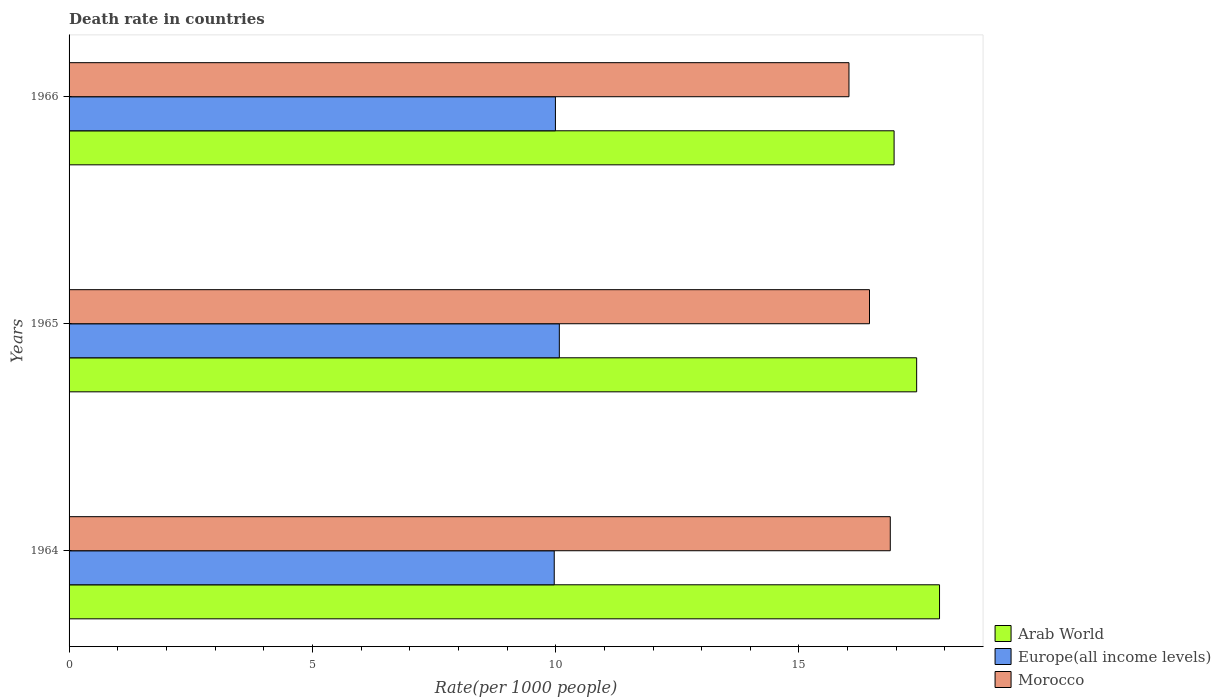How many different coloured bars are there?
Give a very brief answer. 3. Are the number of bars on each tick of the Y-axis equal?
Provide a succinct answer. Yes. What is the label of the 2nd group of bars from the top?
Keep it short and to the point. 1965. In how many cases, is the number of bars for a given year not equal to the number of legend labels?
Ensure brevity in your answer.  0. What is the death rate in Morocco in 1966?
Give a very brief answer. 16.03. Across all years, what is the maximum death rate in Europe(all income levels)?
Your response must be concise. 10.08. Across all years, what is the minimum death rate in Arab World?
Make the answer very short. 16.95. In which year was the death rate in Morocco maximum?
Your answer should be compact. 1964. In which year was the death rate in Morocco minimum?
Ensure brevity in your answer.  1966. What is the total death rate in Arab World in the graph?
Provide a succinct answer. 52.26. What is the difference between the death rate in Morocco in 1964 and that in 1966?
Provide a succinct answer. 0.85. What is the difference between the death rate in Europe(all income levels) in 1966 and the death rate in Arab World in 1964?
Keep it short and to the point. -7.89. What is the average death rate in Arab World per year?
Your answer should be compact. 17.42. In the year 1966, what is the difference between the death rate in Arab World and death rate in Europe(all income levels)?
Give a very brief answer. 6.96. In how many years, is the death rate in Arab World greater than 12 ?
Give a very brief answer. 3. What is the ratio of the death rate in Arab World in 1964 to that in 1965?
Keep it short and to the point. 1.03. What is the difference between the highest and the second highest death rate in Morocco?
Keep it short and to the point. 0.43. What is the difference between the highest and the lowest death rate in Europe(all income levels)?
Keep it short and to the point. 0.1. In how many years, is the death rate in Europe(all income levels) greater than the average death rate in Europe(all income levels) taken over all years?
Your response must be concise. 1. Is the sum of the death rate in Europe(all income levels) in 1964 and 1965 greater than the maximum death rate in Morocco across all years?
Ensure brevity in your answer.  Yes. What does the 3rd bar from the top in 1965 represents?
Provide a succinct answer. Arab World. What does the 2nd bar from the bottom in 1966 represents?
Your answer should be very brief. Europe(all income levels). How many bars are there?
Your answer should be very brief. 9. How many years are there in the graph?
Make the answer very short. 3. What is the difference between two consecutive major ticks on the X-axis?
Ensure brevity in your answer.  5. Are the values on the major ticks of X-axis written in scientific E-notation?
Your answer should be very brief. No. How many legend labels are there?
Your answer should be compact. 3. What is the title of the graph?
Keep it short and to the point. Death rate in countries. Does "North America" appear as one of the legend labels in the graph?
Ensure brevity in your answer.  No. What is the label or title of the X-axis?
Your answer should be very brief. Rate(per 1000 people). What is the label or title of the Y-axis?
Make the answer very short. Years. What is the Rate(per 1000 people) in Arab World in 1964?
Offer a very short reply. 17.89. What is the Rate(per 1000 people) in Europe(all income levels) in 1964?
Offer a terse response. 9.97. What is the Rate(per 1000 people) of Morocco in 1964?
Keep it short and to the point. 16.88. What is the Rate(per 1000 people) in Arab World in 1965?
Offer a very short reply. 17.42. What is the Rate(per 1000 people) of Europe(all income levels) in 1965?
Offer a terse response. 10.08. What is the Rate(per 1000 people) in Morocco in 1965?
Offer a terse response. 16.45. What is the Rate(per 1000 people) in Arab World in 1966?
Your answer should be compact. 16.95. What is the Rate(per 1000 people) in Europe(all income levels) in 1966?
Offer a terse response. 9.99. What is the Rate(per 1000 people) of Morocco in 1966?
Provide a succinct answer. 16.03. Across all years, what is the maximum Rate(per 1000 people) in Arab World?
Your response must be concise. 17.89. Across all years, what is the maximum Rate(per 1000 people) in Europe(all income levels)?
Your response must be concise. 10.08. Across all years, what is the maximum Rate(per 1000 people) in Morocco?
Ensure brevity in your answer.  16.88. Across all years, what is the minimum Rate(per 1000 people) in Arab World?
Offer a terse response. 16.95. Across all years, what is the minimum Rate(per 1000 people) of Europe(all income levels)?
Your response must be concise. 9.97. Across all years, what is the minimum Rate(per 1000 people) in Morocco?
Your response must be concise. 16.03. What is the total Rate(per 1000 people) in Arab World in the graph?
Provide a succinct answer. 52.26. What is the total Rate(per 1000 people) in Europe(all income levels) in the graph?
Make the answer very short. 30.04. What is the total Rate(per 1000 people) in Morocco in the graph?
Give a very brief answer. 49.35. What is the difference between the Rate(per 1000 people) in Arab World in 1964 and that in 1965?
Keep it short and to the point. 0.47. What is the difference between the Rate(per 1000 people) of Europe(all income levels) in 1964 and that in 1965?
Make the answer very short. -0.1. What is the difference between the Rate(per 1000 people) of Morocco in 1964 and that in 1965?
Offer a very short reply. 0.43. What is the difference between the Rate(per 1000 people) of Arab World in 1964 and that in 1966?
Give a very brief answer. 0.93. What is the difference between the Rate(per 1000 people) of Europe(all income levels) in 1964 and that in 1966?
Ensure brevity in your answer.  -0.02. What is the difference between the Rate(per 1000 people) of Morocco in 1964 and that in 1966?
Your response must be concise. 0.85. What is the difference between the Rate(per 1000 people) in Arab World in 1965 and that in 1966?
Your answer should be compact. 0.46. What is the difference between the Rate(per 1000 people) in Europe(all income levels) in 1965 and that in 1966?
Keep it short and to the point. 0.08. What is the difference between the Rate(per 1000 people) of Morocco in 1965 and that in 1966?
Give a very brief answer. 0.42. What is the difference between the Rate(per 1000 people) of Arab World in 1964 and the Rate(per 1000 people) of Europe(all income levels) in 1965?
Your response must be concise. 7.81. What is the difference between the Rate(per 1000 people) in Arab World in 1964 and the Rate(per 1000 people) in Morocco in 1965?
Keep it short and to the point. 1.44. What is the difference between the Rate(per 1000 people) in Europe(all income levels) in 1964 and the Rate(per 1000 people) in Morocco in 1965?
Provide a short and direct response. -6.48. What is the difference between the Rate(per 1000 people) in Arab World in 1964 and the Rate(per 1000 people) in Europe(all income levels) in 1966?
Your response must be concise. 7.89. What is the difference between the Rate(per 1000 people) of Arab World in 1964 and the Rate(per 1000 people) of Morocco in 1966?
Your answer should be very brief. 1.86. What is the difference between the Rate(per 1000 people) in Europe(all income levels) in 1964 and the Rate(per 1000 people) in Morocco in 1966?
Offer a very short reply. -6.06. What is the difference between the Rate(per 1000 people) of Arab World in 1965 and the Rate(per 1000 people) of Europe(all income levels) in 1966?
Ensure brevity in your answer.  7.42. What is the difference between the Rate(per 1000 people) in Arab World in 1965 and the Rate(per 1000 people) in Morocco in 1966?
Keep it short and to the point. 1.39. What is the difference between the Rate(per 1000 people) of Europe(all income levels) in 1965 and the Rate(per 1000 people) of Morocco in 1966?
Your response must be concise. -5.95. What is the average Rate(per 1000 people) of Arab World per year?
Provide a short and direct response. 17.42. What is the average Rate(per 1000 people) in Europe(all income levels) per year?
Keep it short and to the point. 10.01. What is the average Rate(per 1000 people) in Morocco per year?
Keep it short and to the point. 16.45. In the year 1964, what is the difference between the Rate(per 1000 people) of Arab World and Rate(per 1000 people) of Europe(all income levels)?
Provide a short and direct response. 7.92. In the year 1964, what is the difference between the Rate(per 1000 people) of Arab World and Rate(per 1000 people) of Morocco?
Offer a very short reply. 1.01. In the year 1964, what is the difference between the Rate(per 1000 people) of Europe(all income levels) and Rate(per 1000 people) of Morocco?
Your answer should be compact. -6.91. In the year 1965, what is the difference between the Rate(per 1000 people) of Arab World and Rate(per 1000 people) of Europe(all income levels)?
Ensure brevity in your answer.  7.34. In the year 1965, what is the difference between the Rate(per 1000 people) in Arab World and Rate(per 1000 people) in Morocco?
Provide a succinct answer. 0.97. In the year 1965, what is the difference between the Rate(per 1000 people) in Europe(all income levels) and Rate(per 1000 people) in Morocco?
Ensure brevity in your answer.  -6.37. In the year 1966, what is the difference between the Rate(per 1000 people) in Arab World and Rate(per 1000 people) in Europe(all income levels)?
Make the answer very short. 6.96. In the year 1966, what is the difference between the Rate(per 1000 people) in Arab World and Rate(per 1000 people) in Morocco?
Provide a succinct answer. 0.93. In the year 1966, what is the difference between the Rate(per 1000 people) in Europe(all income levels) and Rate(per 1000 people) in Morocco?
Your answer should be very brief. -6.03. What is the ratio of the Rate(per 1000 people) in Arab World in 1964 to that in 1965?
Provide a succinct answer. 1.03. What is the ratio of the Rate(per 1000 people) of Morocco in 1964 to that in 1965?
Offer a terse response. 1.03. What is the ratio of the Rate(per 1000 people) of Arab World in 1964 to that in 1966?
Keep it short and to the point. 1.06. What is the ratio of the Rate(per 1000 people) in Europe(all income levels) in 1964 to that in 1966?
Your answer should be very brief. 1. What is the ratio of the Rate(per 1000 people) of Morocco in 1964 to that in 1966?
Your answer should be compact. 1.05. What is the ratio of the Rate(per 1000 people) in Arab World in 1965 to that in 1966?
Ensure brevity in your answer.  1.03. What is the ratio of the Rate(per 1000 people) in Morocco in 1965 to that in 1966?
Make the answer very short. 1.03. What is the difference between the highest and the second highest Rate(per 1000 people) of Arab World?
Make the answer very short. 0.47. What is the difference between the highest and the second highest Rate(per 1000 people) of Europe(all income levels)?
Keep it short and to the point. 0.08. What is the difference between the highest and the second highest Rate(per 1000 people) of Morocco?
Give a very brief answer. 0.43. What is the difference between the highest and the lowest Rate(per 1000 people) of Arab World?
Keep it short and to the point. 0.93. What is the difference between the highest and the lowest Rate(per 1000 people) in Europe(all income levels)?
Provide a short and direct response. 0.1. What is the difference between the highest and the lowest Rate(per 1000 people) of Morocco?
Offer a terse response. 0.85. 